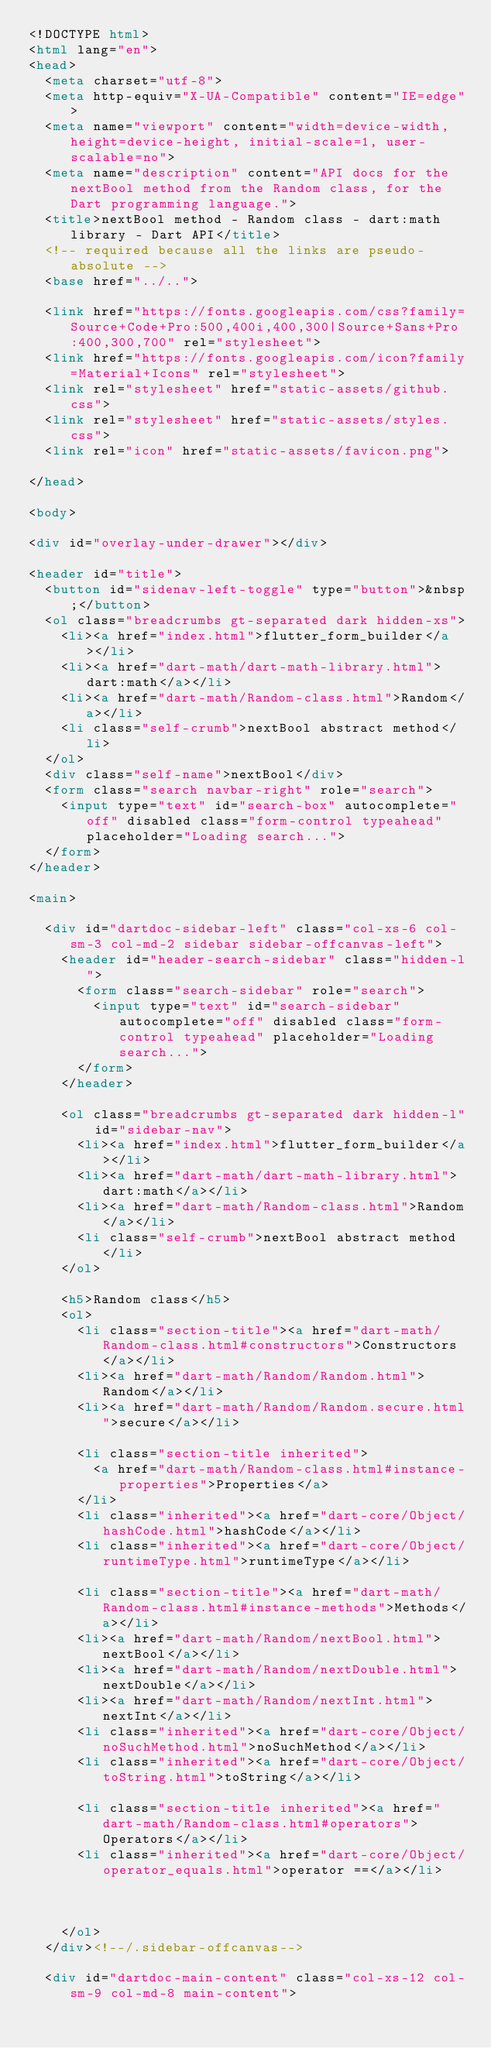Convert code to text. <code><loc_0><loc_0><loc_500><loc_500><_HTML_><!DOCTYPE html>
<html lang="en">
<head>
  <meta charset="utf-8">
  <meta http-equiv="X-UA-Compatible" content="IE=edge">
  <meta name="viewport" content="width=device-width, height=device-height, initial-scale=1, user-scalable=no">
  <meta name="description" content="API docs for the nextBool method from the Random class, for the Dart programming language.">
  <title>nextBool method - Random class - dart:math library - Dart API</title>
  <!-- required because all the links are pseudo-absolute -->
  <base href="../..">

  <link href="https://fonts.googleapis.com/css?family=Source+Code+Pro:500,400i,400,300|Source+Sans+Pro:400,300,700" rel="stylesheet">
  <link href="https://fonts.googleapis.com/icon?family=Material+Icons" rel="stylesheet">
  <link rel="stylesheet" href="static-assets/github.css">
  <link rel="stylesheet" href="static-assets/styles.css">
  <link rel="icon" href="static-assets/favicon.png">
  
</head>

<body>

<div id="overlay-under-drawer"></div>

<header id="title">
  <button id="sidenav-left-toggle" type="button">&nbsp;</button>
  <ol class="breadcrumbs gt-separated dark hidden-xs">
    <li><a href="index.html">flutter_form_builder</a></li>
    <li><a href="dart-math/dart-math-library.html">dart:math</a></li>
    <li><a href="dart-math/Random-class.html">Random</a></li>
    <li class="self-crumb">nextBool abstract method</li>
  </ol>
  <div class="self-name">nextBool</div>
  <form class="search navbar-right" role="search">
    <input type="text" id="search-box" autocomplete="off" disabled class="form-control typeahead" placeholder="Loading search...">
  </form>
</header>

<main>

  <div id="dartdoc-sidebar-left" class="col-xs-6 col-sm-3 col-md-2 sidebar sidebar-offcanvas-left">
    <header id="header-search-sidebar" class="hidden-l">
      <form class="search-sidebar" role="search">
        <input type="text" id="search-sidebar" autocomplete="off" disabled class="form-control typeahead" placeholder="Loading search...">
      </form>
    </header>
    
    <ol class="breadcrumbs gt-separated dark hidden-l" id="sidebar-nav">
      <li><a href="index.html">flutter_form_builder</a></li>
      <li><a href="dart-math/dart-math-library.html">dart:math</a></li>
      <li><a href="dart-math/Random-class.html">Random</a></li>
      <li class="self-crumb">nextBool abstract method</li>
    </ol>
    
    <h5>Random class</h5>
    <ol>
      <li class="section-title"><a href="dart-math/Random-class.html#constructors">Constructors</a></li>
      <li><a href="dart-math/Random/Random.html">Random</a></li>
      <li><a href="dart-math/Random/Random.secure.html">secure</a></li>
    
      <li class="section-title inherited">
        <a href="dart-math/Random-class.html#instance-properties">Properties</a>
      </li>
      <li class="inherited"><a href="dart-core/Object/hashCode.html">hashCode</a></li>
      <li class="inherited"><a href="dart-core/Object/runtimeType.html">runtimeType</a></li>
    
      <li class="section-title"><a href="dart-math/Random-class.html#instance-methods">Methods</a></li>
      <li><a href="dart-math/Random/nextBool.html">nextBool</a></li>
      <li><a href="dart-math/Random/nextDouble.html">nextDouble</a></li>
      <li><a href="dart-math/Random/nextInt.html">nextInt</a></li>
      <li class="inherited"><a href="dart-core/Object/noSuchMethod.html">noSuchMethod</a></li>
      <li class="inherited"><a href="dart-core/Object/toString.html">toString</a></li>
    
      <li class="section-title inherited"><a href="dart-math/Random-class.html#operators">Operators</a></li>
      <li class="inherited"><a href="dart-core/Object/operator_equals.html">operator ==</a></li>
    
    
    
    </ol>
  </div><!--/.sidebar-offcanvas-->

  <div id="dartdoc-main-content" class="col-xs-12 col-sm-9 col-md-8 main-content"></code> 